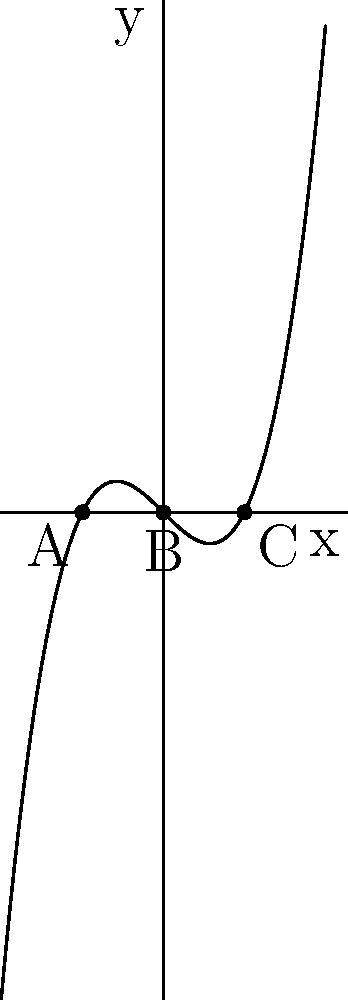In the graph above, the curve represents the function $f(x) = x^3 - x$, and the roots of the equation $f(x) = 0$ are labeled A, B, and C. How might these roots be interpreted as representing different stages or aspects of a philosophical argument, and what could the shape of the curve suggest about the nature of philosophical reasoning? To interpret this graph in a philosophical context, we can follow these steps:

1. Identify the roots: The roots A (-1, 0), B (0, 0), and C (1, 0) represent key points in our philosophical argument.

2. Interpret the roots:
   A: Could represent the initial thesis or proposition.
   B: Might symbolize a point of equilibrium or neutrality.
   C: Could represent the antithesis or counter-argument.

3. Analyze the curve's shape:
   - The curve passes through all three points, suggesting a continuous line of reasoning.
   - It's symmetric around the origin (B), implying balance in the argument.
   - The curve extends infinitely in both directions, possibly representing the boundless nature of philosophical inquiry.

4. Examine the function:
   $f(x) = x^3 - x$ can be factored as $x(x^2 - 1)$ or $x(x-1)(x+1)$, showing the interconnectedness of the three points.

5. Consider the areas between the roots:
   - The area between A and B could represent the exploration of the initial thesis.
   - The area between B and C might symbolize the development of the antithesis.
   - The areas beyond A and C could suggest the implications and extensions of the argument.

6. Reflect on the curve's behavior:
   - The curve's rising and falling nature might represent the ebb and flow of philosophical discourse.
   - The inflection point at (0,0) could symbolize a crucial turning point in the argument.

This interpretation illustrates how mathematical concepts can be used as a metaphor for complex philosophical ideas, demonstrating the power of visual representation in conveying abstract concepts.
Answer: Roots as thesis (A), equilibrium (B), and antithesis (C); curve shape symbolizes continuous, balanced reasoning and boundless inquiry. 